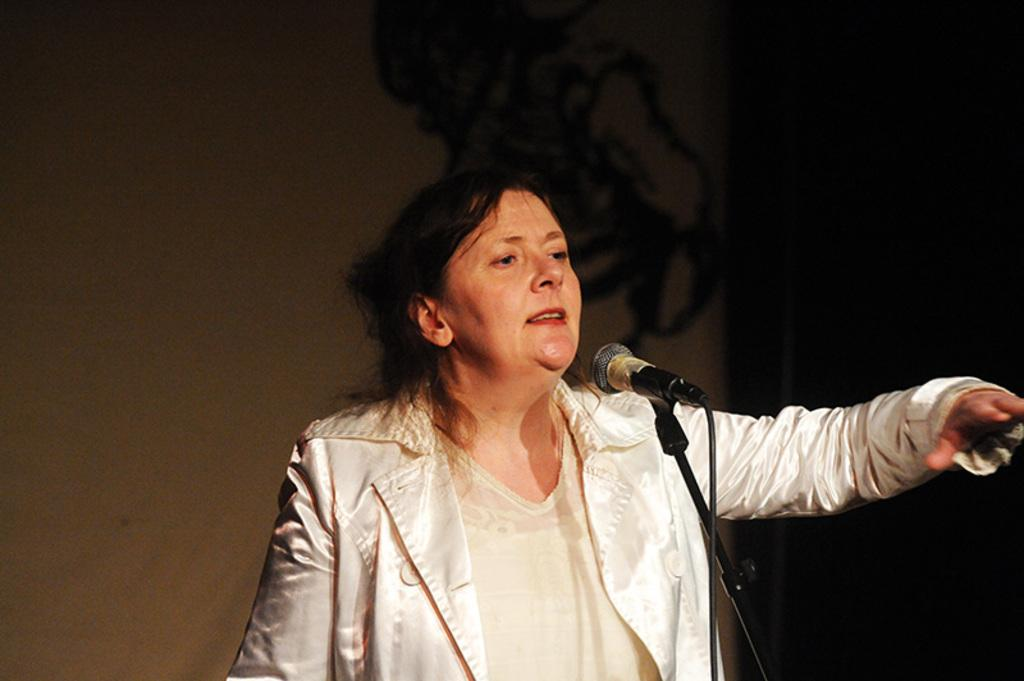Who is the main subject in the image? There is a lady in the center of the image. What object is in front of the lady? There is a microphone (mic) in front of the lady. What month is it in the image? The month cannot be determined from the image, as there is no information about the date or time. 